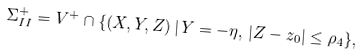<formula> <loc_0><loc_0><loc_500><loc_500>\Sigma ^ { + } _ { I I } = V ^ { + } \cap \{ ( X , Y , Z ) \, | \, Y = - \eta , \, | Z - z _ { 0 } | \leq \rho _ { 4 } \} ,</formula> 